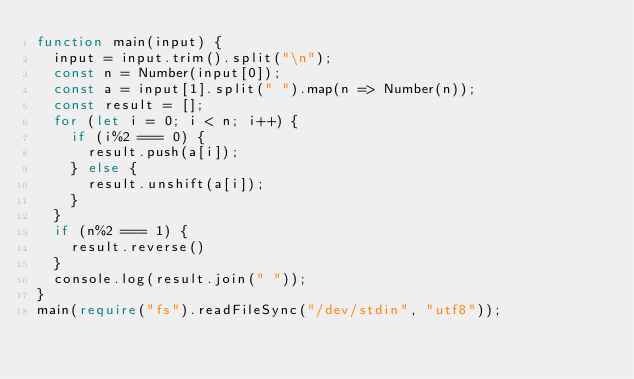<code> <loc_0><loc_0><loc_500><loc_500><_TypeScript_>function main(input) {
  input = input.trim().split("\n");
  const n = Number(input[0]);
  const a = input[1].split(" ").map(n => Number(n));
  const result = [];
  for (let i = 0; i < n; i++) {
    if (i%2 === 0) {
      result.push(a[i]);
    } else {
      result.unshift(a[i]);
    }
  }
  if (n%2 === 1) {
    result.reverse()
  }
  console.log(result.join(" "));
}
main(require("fs").readFileSync("/dev/stdin", "utf8"));
</code> 